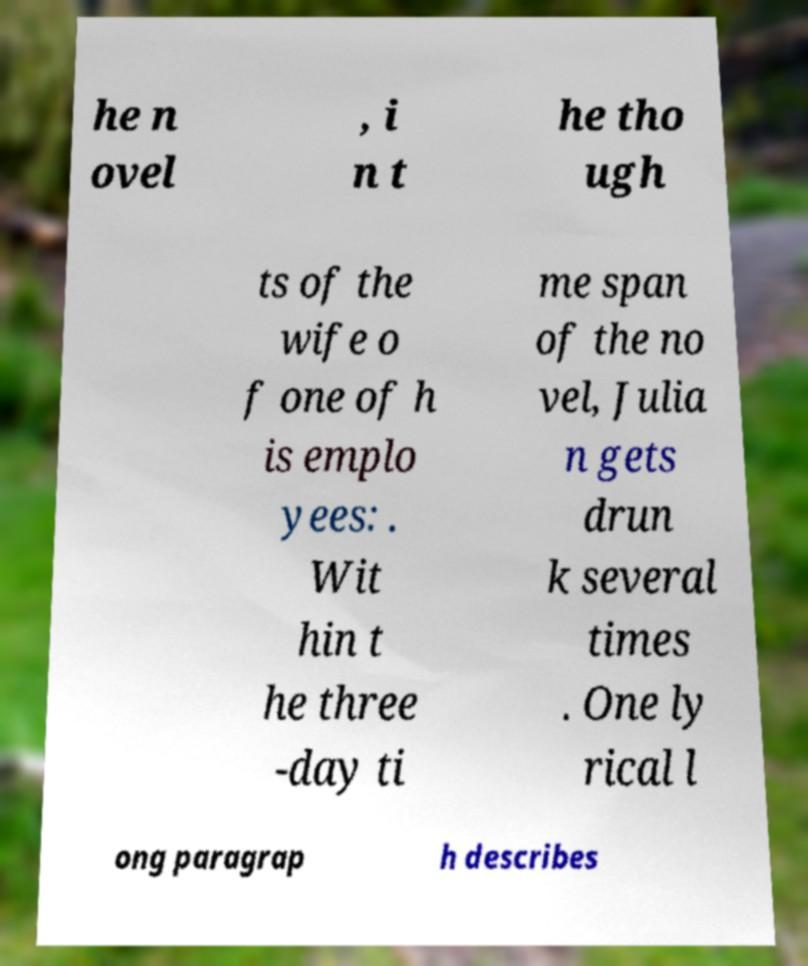What messages or text are displayed in this image? I need them in a readable, typed format. he n ovel , i n t he tho ugh ts of the wife o f one of h is emplo yees: . Wit hin t he three -day ti me span of the no vel, Julia n gets drun k several times . One ly rical l ong paragrap h describes 